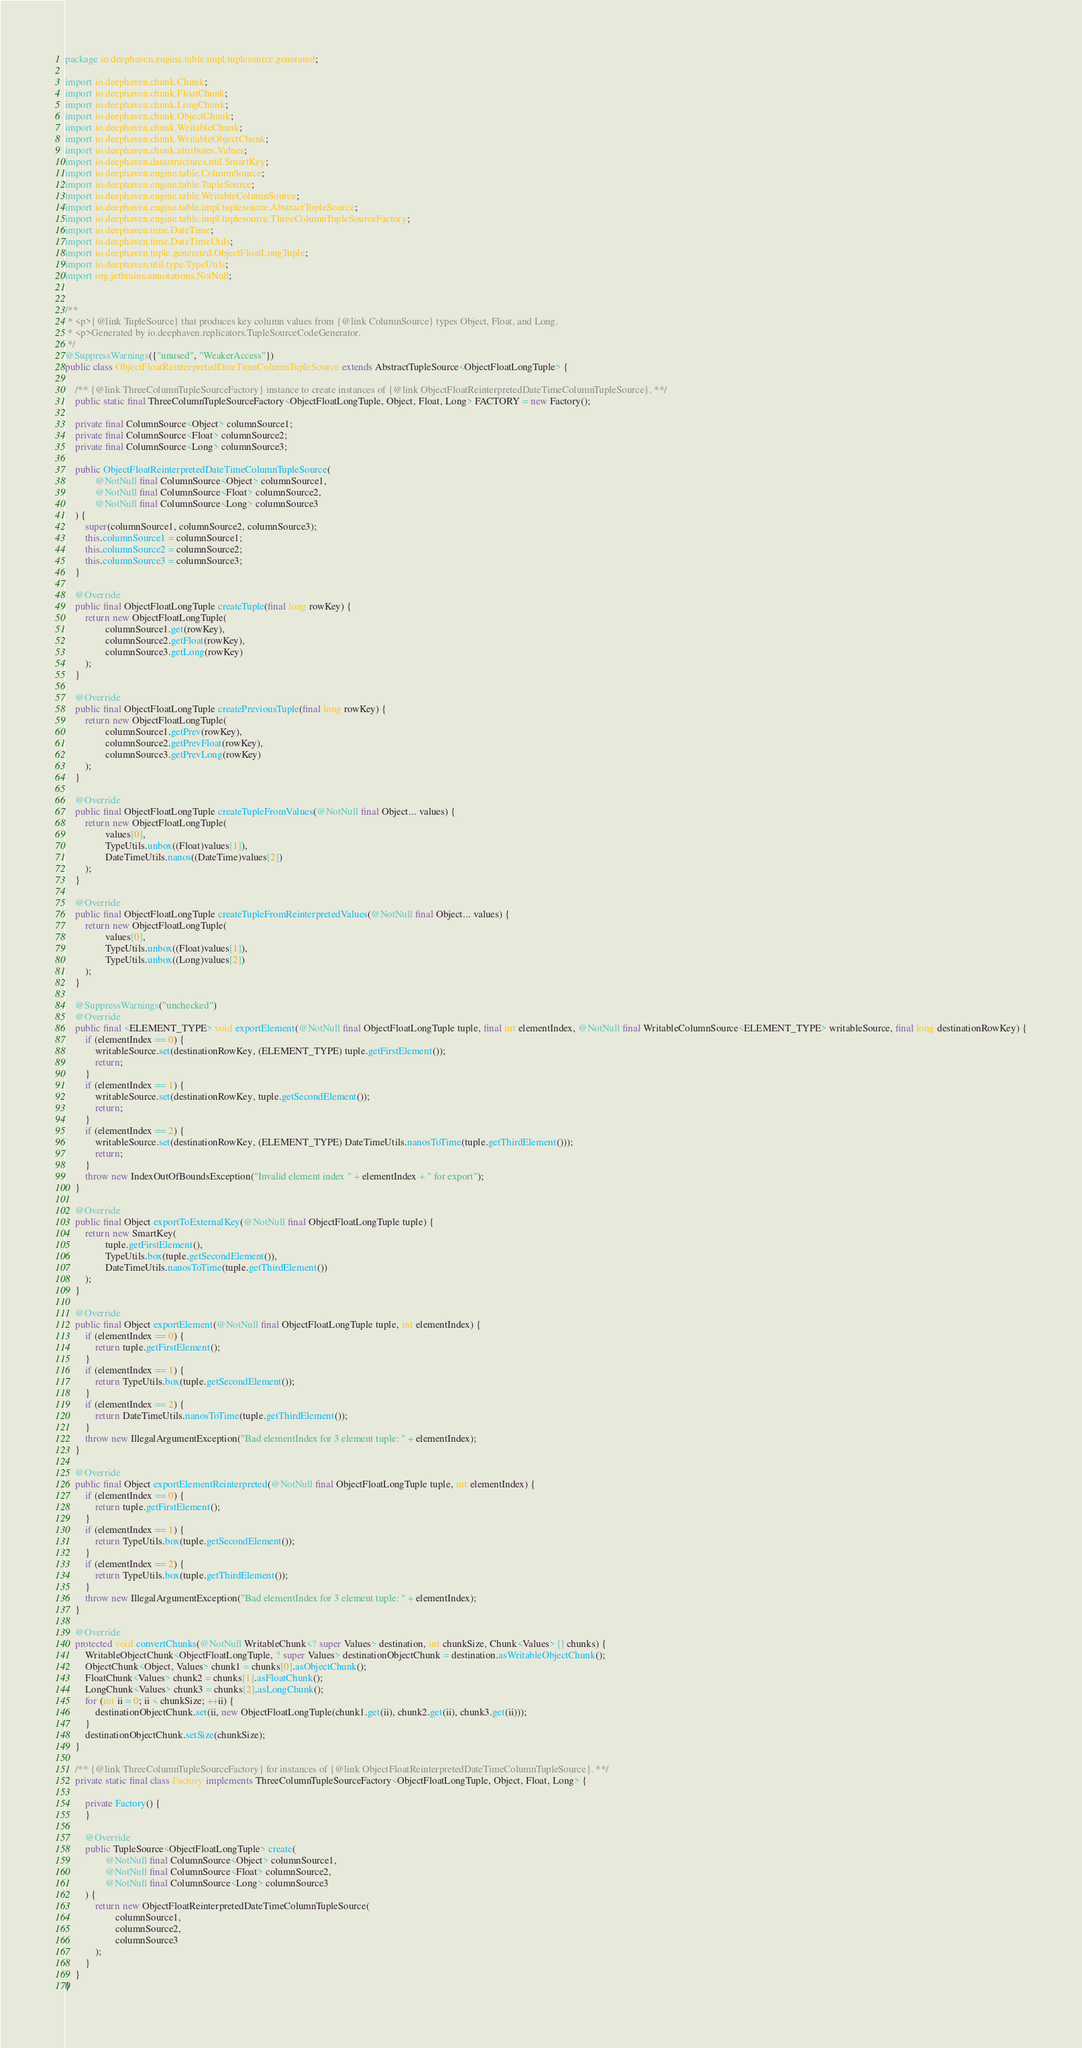<code> <loc_0><loc_0><loc_500><loc_500><_Java_>package io.deephaven.engine.table.impl.tuplesource.generated;

import io.deephaven.chunk.Chunk;
import io.deephaven.chunk.FloatChunk;
import io.deephaven.chunk.LongChunk;
import io.deephaven.chunk.ObjectChunk;
import io.deephaven.chunk.WritableChunk;
import io.deephaven.chunk.WritableObjectChunk;
import io.deephaven.chunk.attributes.Values;
import io.deephaven.datastructures.util.SmartKey;
import io.deephaven.engine.table.ColumnSource;
import io.deephaven.engine.table.TupleSource;
import io.deephaven.engine.table.WritableColumnSource;
import io.deephaven.engine.table.impl.tuplesource.AbstractTupleSource;
import io.deephaven.engine.table.impl.tuplesource.ThreeColumnTupleSourceFactory;
import io.deephaven.time.DateTime;
import io.deephaven.time.DateTimeUtils;
import io.deephaven.tuple.generated.ObjectFloatLongTuple;
import io.deephaven.util.type.TypeUtils;
import org.jetbrains.annotations.NotNull;


/**
 * <p>{@link TupleSource} that produces key column values from {@link ColumnSource} types Object, Float, and Long.
 * <p>Generated by io.deephaven.replicators.TupleSourceCodeGenerator.
 */
@SuppressWarnings({"unused", "WeakerAccess"})
public class ObjectFloatReinterpretedDateTimeColumnTupleSource extends AbstractTupleSource<ObjectFloatLongTuple> {

    /** {@link ThreeColumnTupleSourceFactory} instance to create instances of {@link ObjectFloatReinterpretedDateTimeColumnTupleSource}. **/
    public static final ThreeColumnTupleSourceFactory<ObjectFloatLongTuple, Object, Float, Long> FACTORY = new Factory();

    private final ColumnSource<Object> columnSource1;
    private final ColumnSource<Float> columnSource2;
    private final ColumnSource<Long> columnSource3;

    public ObjectFloatReinterpretedDateTimeColumnTupleSource(
            @NotNull final ColumnSource<Object> columnSource1,
            @NotNull final ColumnSource<Float> columnSource2,
            @NotNull final ColumnSource<Long> columnSource3
    ) {
        super(columnSource1, columnSource2, columnSource3);
        this.columnSource1 = columnSource1;
        this.columnSource2 = columnSource2;
        this.columnSource3 = columnSource3;
    }

    @Override
    public final ObjectFloatLongTuple createTuple(final long rowKey) {
        return new ObjectFloatLongTuple(
                columnSource1.get(rowKey),
                columnSource2.getFloat(rowKey),
                columnSource3.getLong(rowKey)
        );
    }

    @Override
    public final ObjectFloatLongTuple createPreviousTuple(final long rowKey) {
        return new ObjectFloatLongTuple(
                columnSource1.getPrev(rowKey),
                columnSource2.getPrevFloat(rowKey),
                columnSource3.getPrevLong(rowKey)
        );
    }

    @Override
    public final ObjectFloatLongTuple createTupleFromValues(@NotNull final Object... values) {
        return new ObjectFloatLongTuple(
                values[0],
                TypeUtils.unbox((Float)values[1]),
                DateTimeUtils.nanos((DateTime)values[2])
        );
    }

    @Override
    public final ObjectFloatLongTuple createTupleFromReinterpretedValues(@NotNull final Object... values) {
        return new ObjectFloatLongTuple(
                values[0],
                TypeUtils.unbox((Float)values[1]),
                TypeUtils.unbox((Long)values[2])
        );
    }

    @SuppressWarnings("unchecked")
    @Override
    public final <ELEMENT_TYPE> void exportElement(@NotNull final ObjectFloatLongTuple tuple, final int elementIndex, @NotNull final WritableColumnSource<ELEMENT_TYPE> writableSource, final long destinationRowKey) {
        if (elementIndex == 0) {
            writableSource.set(destinationRowKey, (ELEMENT_TYPE) tuple.getFirstElement());
            return;
        }
        if (elementIndex == 1) {
            writableSource.set(destinationRowKey, tuple.getSecondElement());
            return;
        }
        if (elementIndex == 2) {
            writableSource.set(destinationRowKey, (ELEMENT_TYPE) DateTimeUtils.nanosToTime(tuple.getThirdElement()));
            return;
        }
        throw new IndexOutOfBoundsException("Invalid element index " + elementIndex + " for export");
    }

    @Override
    public final Object exportToExternalKey(@NotNull final ObjectFloatLongTuple tuple) {
        return new SmartKey(
                tuple.getFirstElement(),
                TypeUtils.box(tuple.getSecondElement()),
                DateTimeUtils.nanosToTime(tuple.getThirdElement())
        );
    }

    @Override
    public final Object exportElement(@NotNull final ObjectFloatLongTuple tuple, int elementIndex) {
        if (elementIndex == 0) {
            return tuple.getFirstElement();
        }
        if (elementIndex == 1) {
            return TypeUtils.box(tuple.getSecondElement());
        }
        if (elementIndex == 2) {
            return DateTimeUtils.nanosToTime(tuple.getThirdElement());
        }
        throw new IllegalArgumentException("Bad elementIndex for 3 element tuple: " + elementIndex);
    }

    @Override
    public final Object exportElementReinterpreted(@NotNull final ObjectFloatLongTuple tuple, int elementIndex) {
        if (elementIndex == 0) {
            return tuple.getFirstElement();
        }
        if (elementIndex == 1) {
            return TypeUtils.box(tuple.getSecondElement());
        }
        if (elementIndex == 2) {
            return TypeUtils.box(tuple.getThirdElement());
        }
        throw new IllegalArgumentException("Bad elementIndex for 3 element tuple: " + elementIndex);
    }

    @Override
    protected void convertChunks(@NotNull WritableChunk<? super Values> destination, int chunkSize, Chunk<Values> [] chunks) {
        WritableObjectChunk<ObjectFloatLongTuple, ? super Values> destinationObjectChunk = destination.asWritableObjectChunk();
        ObjectChunk<Object, Values> chunk1 = chunks[0].asObjectChunk();
        FloatChunk<Values> chunk2 = chunks[1].asFloatChunk();
        LongChunk<Values> chunk3 = chunks[2].asLongChunk();
        for (int ii = 0; ii < chunkSize; ++ii) {
            destinationObjectChunk.set(ii, new ObjectFloatLongTuple(chunk1.get(ii), chunk2.get(ii), chunk3.get(ii)));
        }
        destinationObjectChunk.setSize(chunkSize);
    }

    /** {@link ThreeColumnTupleSourceFactory} for instances of {@link ObjectFloatReinterpretedDateTimeColumnTupleSource}. **/
    private static final class Factory implements ThreeColumnTupleSourceFactory<ObjectFloatLongTuple, Object, Float, Long> {

        private Factory() {
        }

        @Override
        public TupleSource<ObjectFloatLongTuple> create(
                @NotNull final ColumnSource<Object> columnSource1,
                @NotNull final ColumnSource<Float> columnSource2,
                @NotNull final ColumnSource<Long> columnSource3
        ) {
            return new ObjectFloatReinterpretedDateTimeColumnTupleSource(
                    columnSource1,
                    columnSource2,
                    columnSource3
            );
        }
    }
}
</code> 